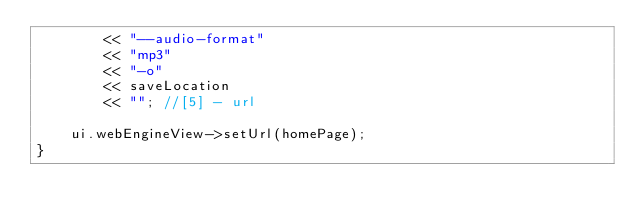Convert code to text. <code><loc_0><loc_0><loc_500><loc_500><_C++_>		<< "--audio-format"
		<< "mp3"
		<< "-o"
		<< saveLocation
		<< ""; //[5] - url

	ui.webEngineView->setUrl(homePage);
}
</code> 